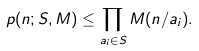Convert formula to latex. <formula><loc_0><loc_0><loc_500><loc_500>p ( n ; S , M ) \leq \prod _ { a _ { i } \in S } M ( n / a _ { i } ) .</formula> 